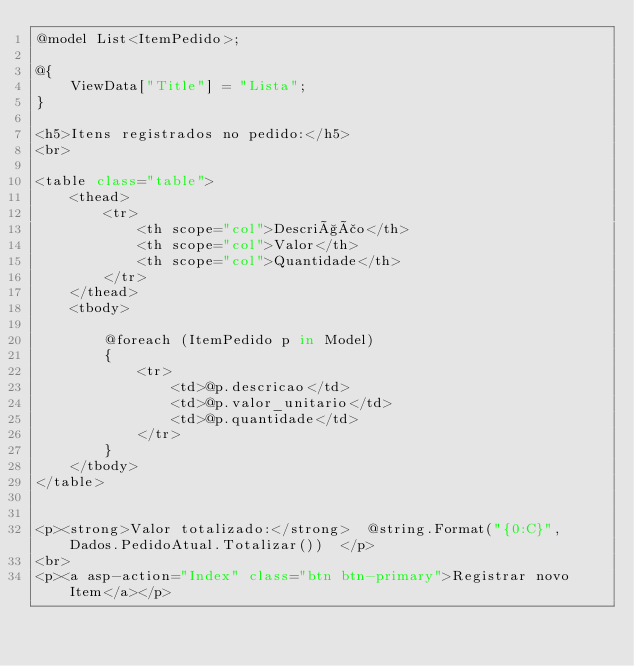<code> <loc_0><loc_0><loc_500><loc_500><_C#_>@model List<ItemPedido>;

@{
    ViewData["Title"] = "Lista";
}

<h5>Itens registrados no pedido:</h5>
<br>

<table class="table">
    <thead>
        <tr>
            <th scope="col">Descrição</th>
            <th scope="col">Valor</th>
            <th scope="col">Quantidade</th>
        </tr>
    </thead>
    <tbody>
        
        @foreach (ItemPedido p in Model)
        {
            <tr>
                <td>@p.descricao</td>
                <td>@p.valor_unitario</td>
                <td>@p.quantidade</td>
            </tr>
        }
    </tbody>
</table>


<p><strong>Valor totalizado:</strong>  @string.Format("{0:C}", Dados.PedidoAtual.Totalizar())  </p>
<br>
<p><a asp-action="Index" class="btn btn-primary">Registrar novo Item</a></p>
</code> 